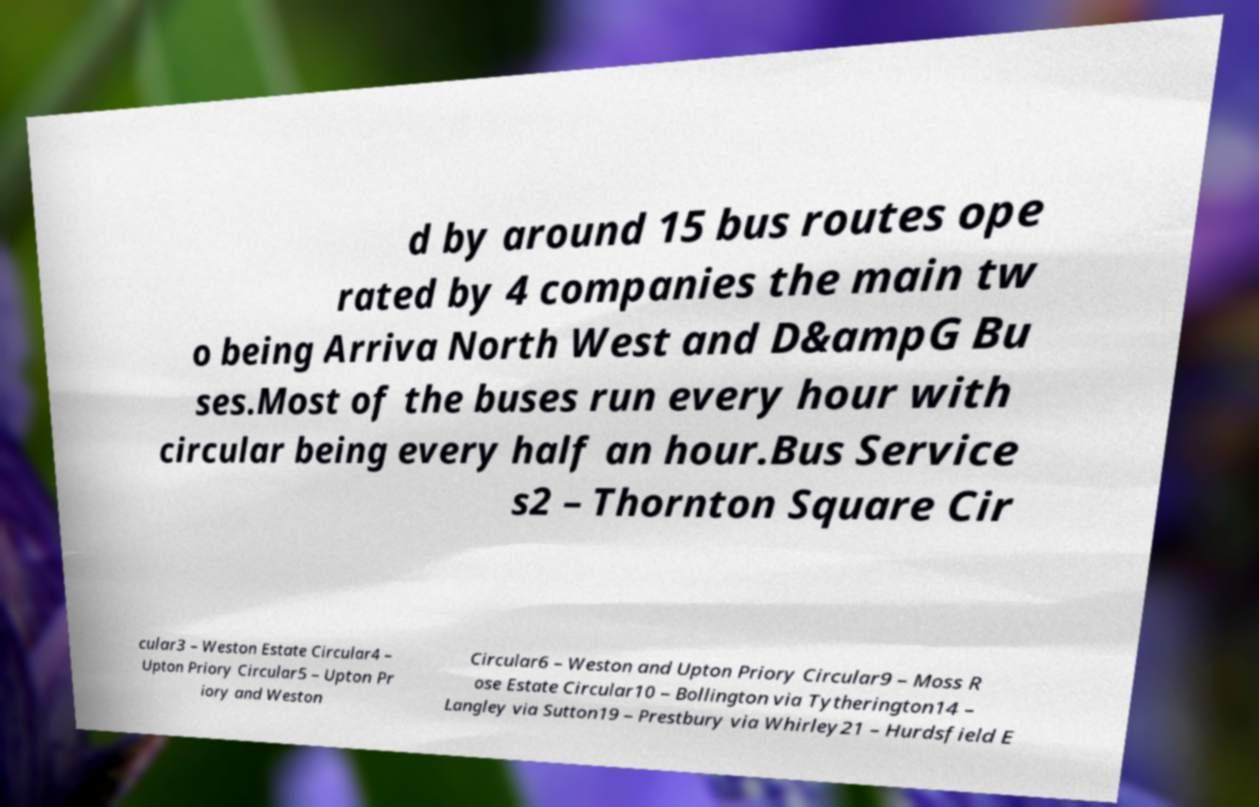Can you accurately transcribe the text from the provided image for me? d by around 15 bus routes ope rated by 4 companies the main tw o being Arriva North West and D&ampG Bu ses.Most of the buses run every hour with circular being every half an hour.Bus Service s2 – Thornton Square Cir cular3 – Weston Estate Circular4 – Upton Priory Circular5 – Upton Pr iory and Weston Circular6 – Weston and Upton Priory Circular9 – Moss R ose Estate Circular10 – Bollington via Tytherington14 – Langley via Sutton19 – Prestbury via Whirley21 – Hurdsfield E 